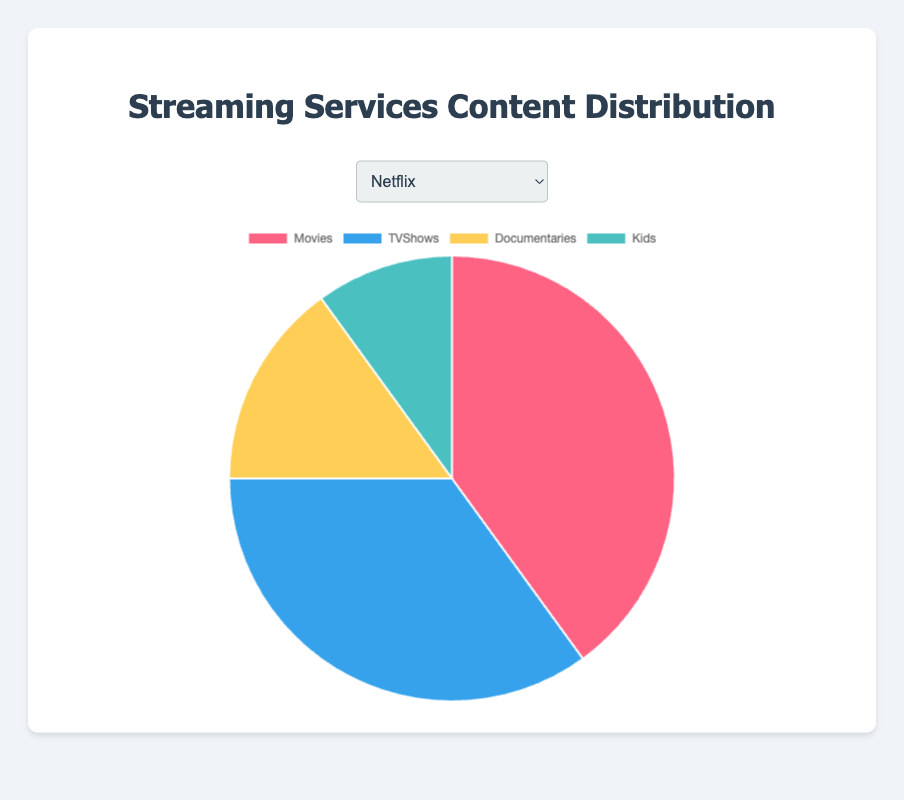Which streaming service has the highest percentage of content geared towards Kids? By looking at the pie charts, Disney+ has the largest slice devoted to Kids content, at 50%, which is the highest percentage among all the services
Answer: Disney+ Does Netflix or Hulu have a higher percentage of Movies content? Compare the sections labeled "Movies" on both the Netflix and Hulu pie charts. Netflix has Movies making up 40% of its content while Hulu has 30% for Movies.
Answer: Netflix Which service has the smallest share of Documentaries content? By examining the pie charts, Disney+ has the smallest section labeled "Documentaries," with only 5%
Answer: Disney+ Which streaming service has the most evenly distributed content among the four categories? Look for the service pie chart where the slices are closest in size. Hulu shows a more balanced distribution with Movies (30%), TVShows (50%), Documentaries (10%), and Kids (10%).
Answer: Hulu Comparing Amazon Prime Video and Apple TV+, which service has a higher percentage of TV Shows content? Look at the sections labeled "TVShows" on both pie charts. Amazon Prime Video has 30% for TVShows, while Apple TV+ has 60%.
Answer: Apple TV+ If you add the percentage of Movies and Kids content in HBO Max, what is the total? Sum the percentages for Movies and Kids on the HBO Max pie chart: 35% (Movies) + 5% (Kids) = 40%
Answer: 40% Comparing Documentary content across all services, which two services have the same percentage? Examine the sections labeled "Documentaries" on each pie chart. Netflix and Apple TV+ both have Documentaries making up 15% of their content.
Answer: Netflix and Apple TV+ Which service has the largest percentage dedicated to TV Shows? Look for the service with the largest slice labeled "TVShows." Apple TV+ has the biggest share at 60%.
Answer: Apple TV+ If you combine the percentages of Movies and TV Shows for Disney+, what is the total percentage? Add the percentages for Movies and TVShows on Disney+'s chart: 25% (Movies) + 20% (TVShows) = 45%
Answer: 45% 